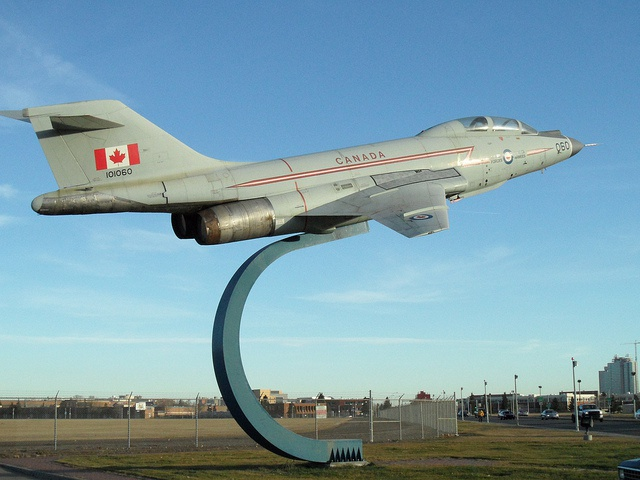Describe the objects in this image and their specific colors. I can see airplane in gray, darkgray, lightgray, and beige tones, car in gray, black, navy, and teal tones, car in gray, black, purple, and darkgray tones, car in gray, black, blue, and darkblue tones, and car in gray, black, and darkblue tones in this image. 